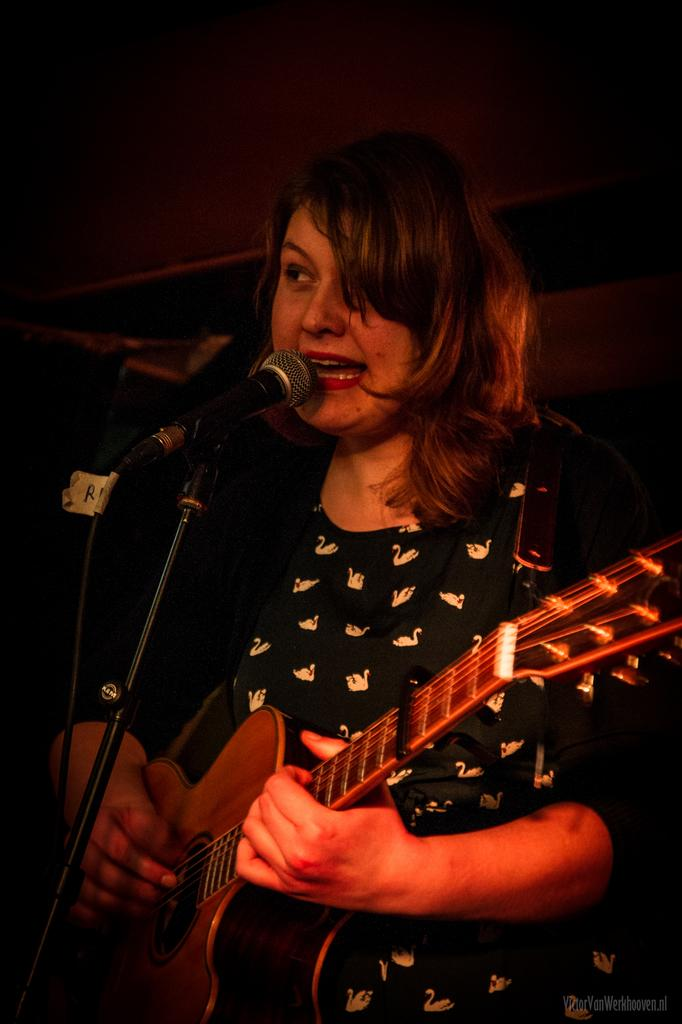What is the main subject of the image? The main subject of the image is a woman. What is the woman doing in the image? The woman is standing, playing a guitar, singing a song, and using a microphone. Can you see a boat in the image? There is no boat present in the image. Is there a bear accompanying the woman in the image? There is no bear present in the image. 